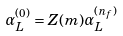<formula> <loc_0><loc_0><loc_500><loc_500>\alpha _ { L } ^ { ( 0 ) } = Z ( m ) \alpha _ { L } ^ { ( n _ { f } ) }</formula> 